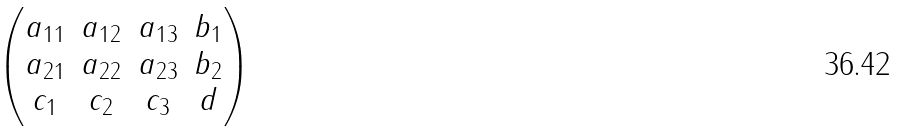Convert formula to latex. <formula><loc_0><loc_0><loc_500><loc_500>\begin{pmatrix} a _ { 1 1 } & a _ { 1 2 } & a _ { 1 3 } & b _ { 1 } \\ a _ { 2 1 } & a _ { 2 2 } & a _ { 2 3 } & b _ { 2 } \\ c _ { 1 } & c _ { 2 } & c _ { 3 } & d \end{pmatrix}</formula> 